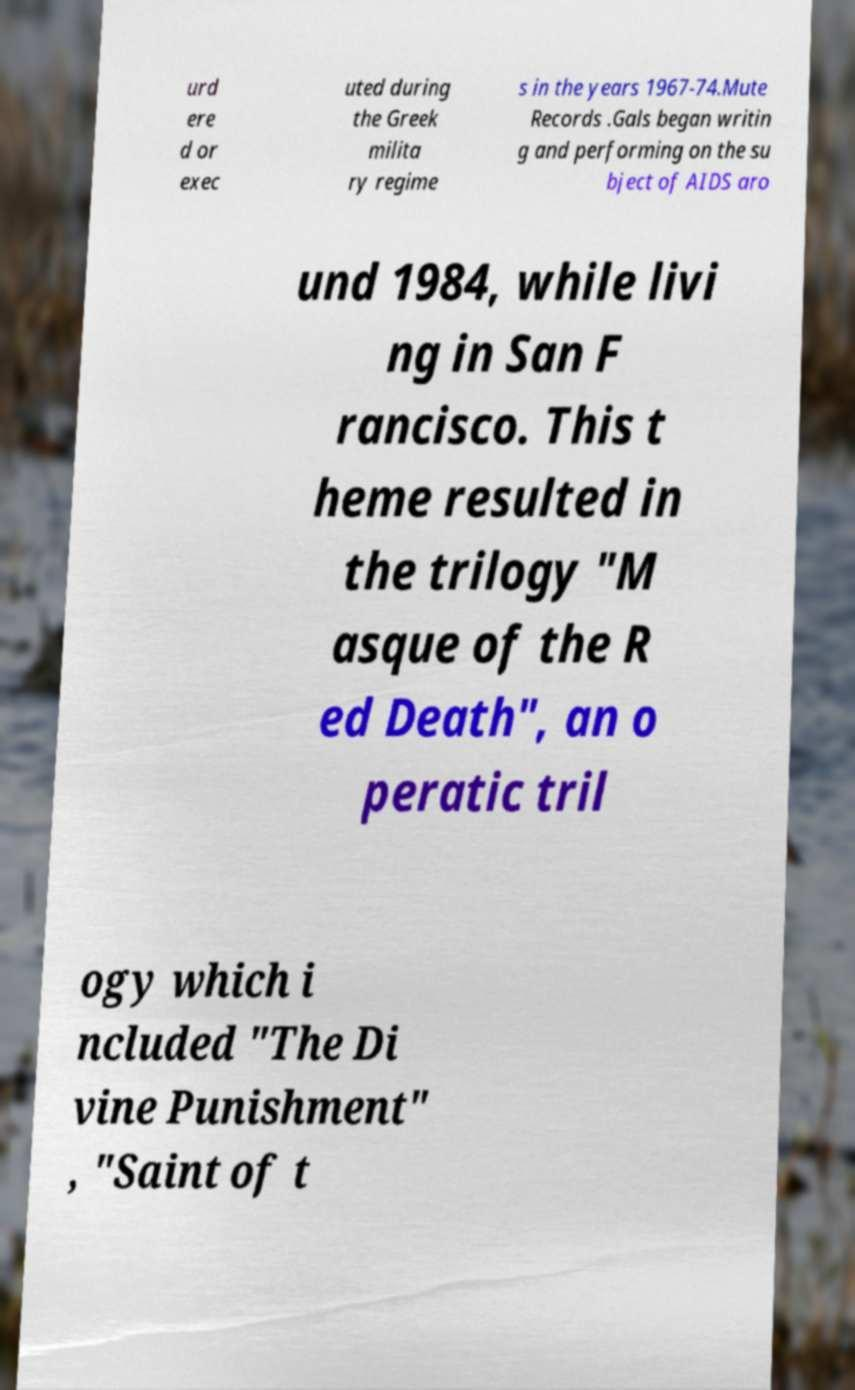Can you accurately transcribe the text from the provided image for me? urd ere d or exec uted during the Greek milita ry regime s in the years 1967-74.Mute Records .Gals began writin g and performing on the su bject of AIDS aro und 1984, while livi ng in San F rancisco. This t heme resulted in the trilogy "M asque of the R ed Death", an o peratic tril ogy which i ncluded "The Di vine Punishment" , "Saint of t 